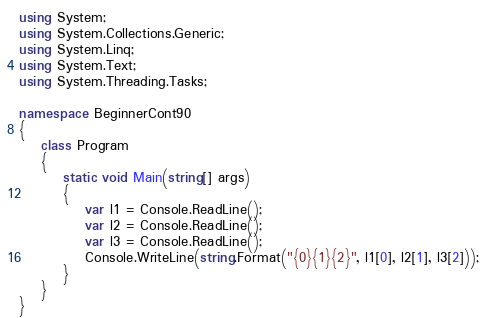<code> <loc_0><loc_0><loc_500><loc_500><_C#_>using System;
using System.Collections.Generic;
using System.Linq;
using System.Text;
using System.Threading.Tasks;

namespace BeginnerCont90
{
    class Program
    {
        static void Main(string[] args)
        {
            var l1 = Console.ReadLine();
            var l2 = Console.ReadLine();
            var l3 = Console.ReadLine();
            Console.WriteLine(string.Format("{0}{1}{2}", l1[0], l2[1], l3[2]));
        }
    }
}
</code> 